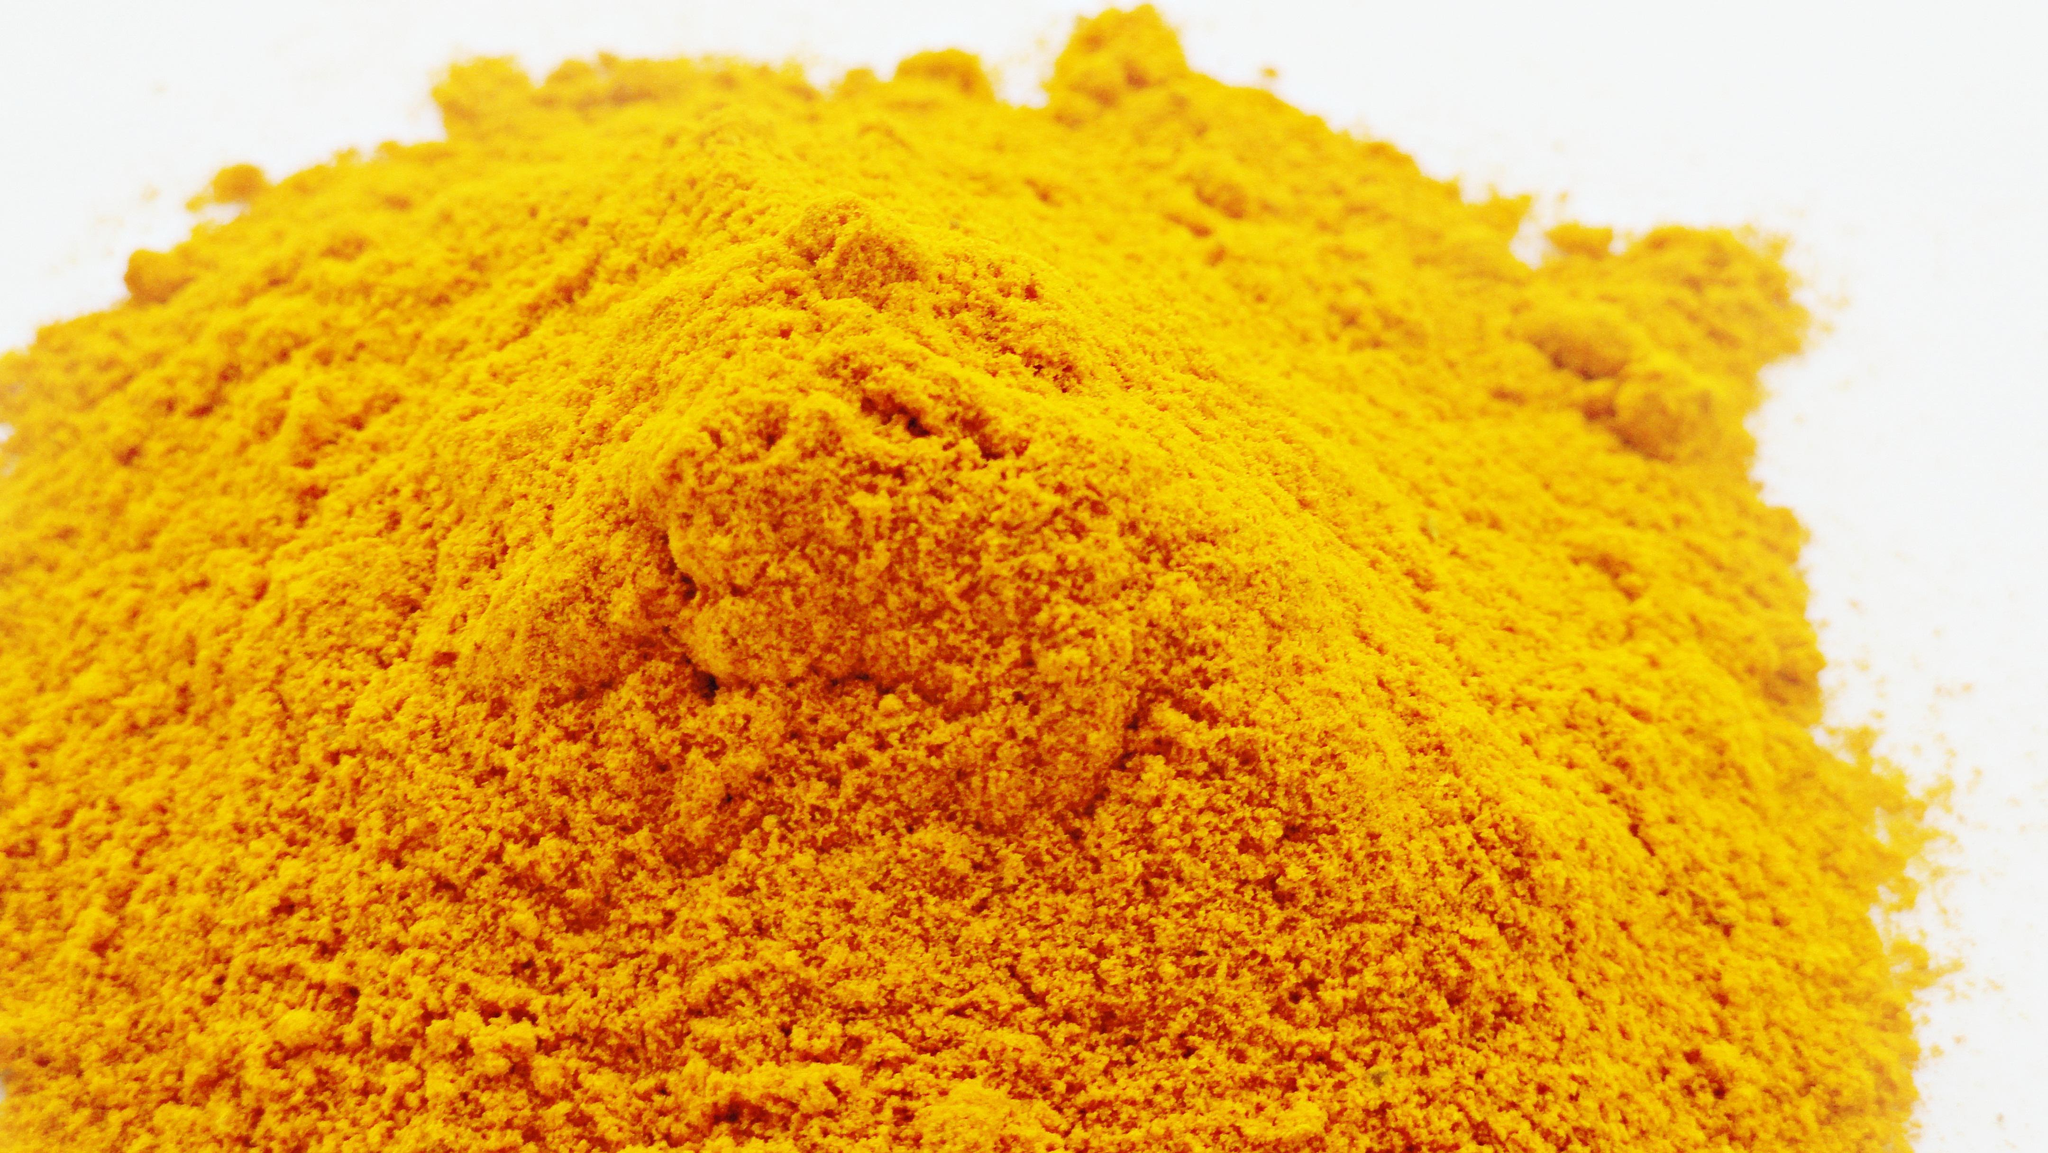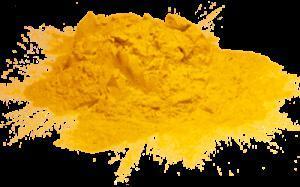The first image is the image on the left, the second image is the image on the right. Analyze the images presented: Is the assertion "One or more of the photos depict yellow-orange powder arranged in a mound." valid? Answer yes or no. Yes. The first image is the image on the left, the second image is the image on the right. For the images displayed, is the sentence "An image shows a mostly round pile of golden-yellow powder." factually correct? Answer yes or no. Yes. 